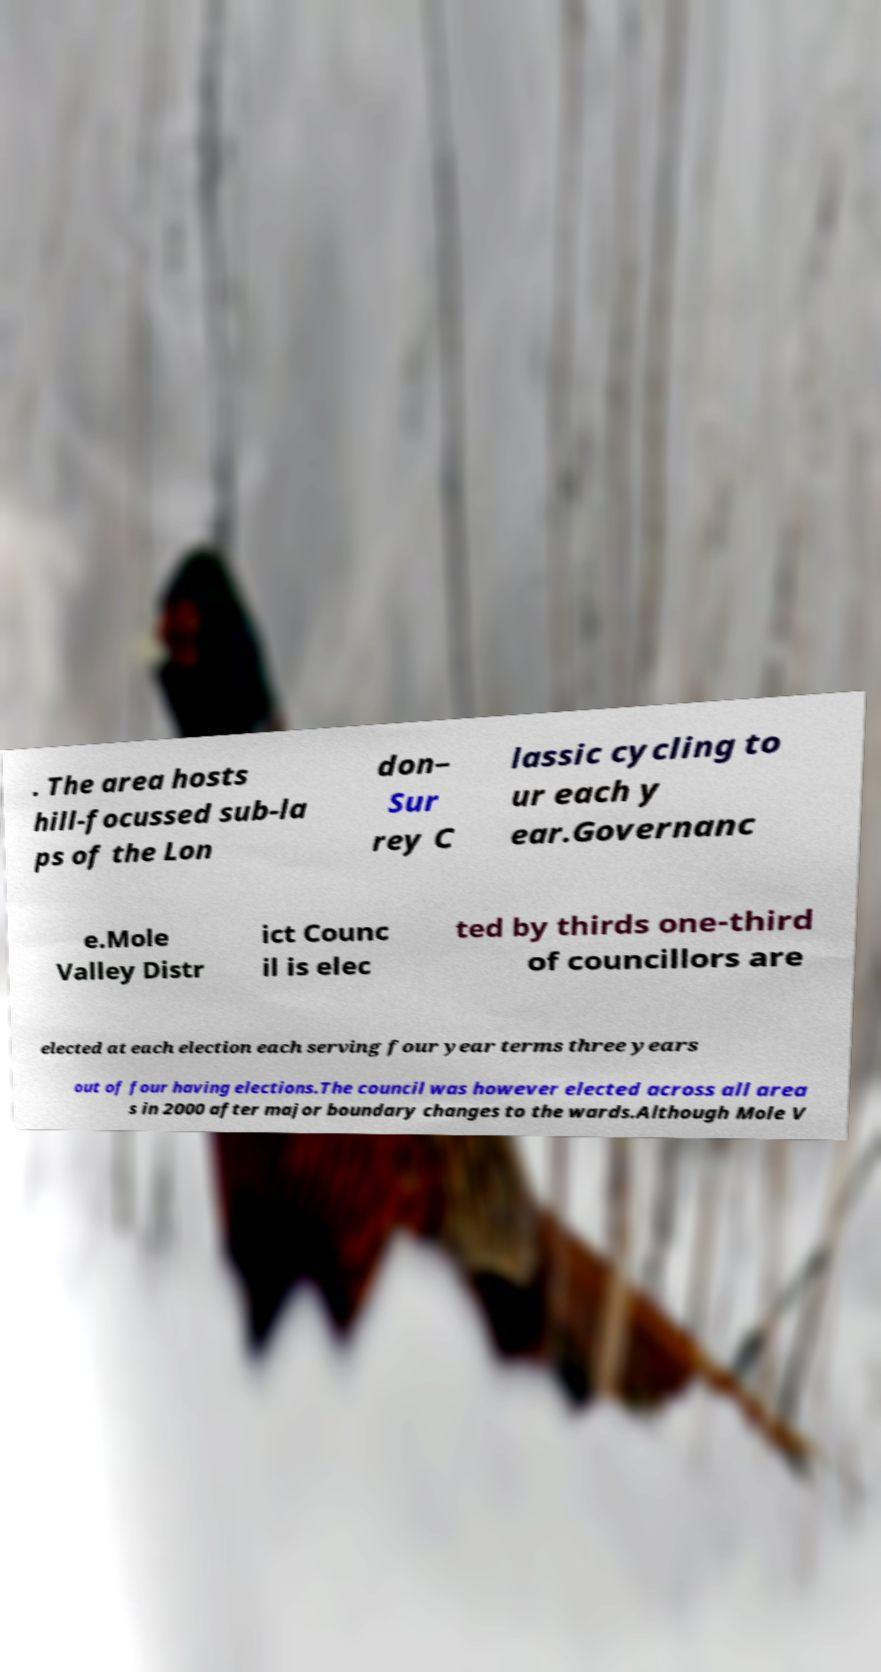For documentation purposes, I need the text within this image transcribed. Could you provide that? . The area hosts hill-focussed sub-la ps of the Lon don– Sur rey C lassic cycling to ur each y ear.Governanc e.Mole Valley Distr ict Counc il is elec ted by thirds one-third of councillors are elected at each election each serving four year terms three years out of four having elections.The council was however elected across all area s in 2000 after major boundary changes to the wards.Although Mole V 